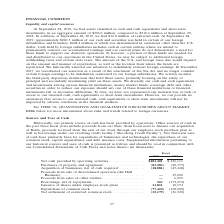According to Coherent's financial document, What was the Net cash provided by operating activities in 2019? According to the financial document, $181,401 (in thousands). The relevant text states: "Net cash provided by operating activities . $181,401 $ 236,111 Purchases of property and equipment . (83,283) (90,757) Acquisition of businesses, net of..." Also, What was the  Purchases of property and equipment  in 2018? According to the financial document, (90,757) (in thousands). The relevant text states: "111 Purchases of property and equipment . (83,283) (90,757) Acquisition of businesses, net of cash acquired . (18,881) (45,448) Proceeds from sale of discontinu..." Also, In which years are the uses of cash highlighted in the table? The document shows two values: 2019 and 2018. From the document: "Fiscal 2019 2018 Fiscal 2019 2018..." Additionally, In which year was the Issuance of shares under employee stock plans larger? According to the financial document, 2019. The relevant text states: "Fiscal 2019 2018..." Also, can you calculate: What was the change in Issuance of shares under employee stock plans in 2019 from 2018? Based on the calculation: 11,811-10,574, the result is 1237 (in thousands). This is based on the information: "nce of shares under employee stock plans . 11,811 10,574 Repurchase of common stock . (77,410) (100,000) Net settlement of restricted common stock . (15,179 ) Issuance of shares under employee stock p..." The key data points involved are: 10,574, 11,811. Also, can you calculate: What was the percentage change in Issuance of shares under employee stock plans in 2019 from 2018? To answer this question, I need to perform calculations using the financial data. The calculation is: (11,811-10,574)/10,574, which equals 11.7 (percentage). This is based on the information: "nce of shares under employee stock plans . 11,811 10,574 Repurchase of common stock . (77,410) (100,000) Net settlement of restricted common stock . (15,179 ) Issuance of shares under employee stock p..." The key data points involved are: 10,574, 11,811. 